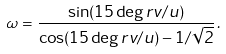<formula> <loc_0><loc_0><loc_500><loc_500>\omega = \frac { \sin ( 1 5 \deg r v / u ) } { \cos ( 1 5 \deg r v / u ) - 1 / \sqrt { 2 } } \, .</formula> 